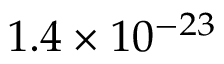Convert formula to latex. <formula><loc_0><loc_0><loc_500><loc_500>1 . 4 \times 1 0 ^ { - 2 3 }</formula> 